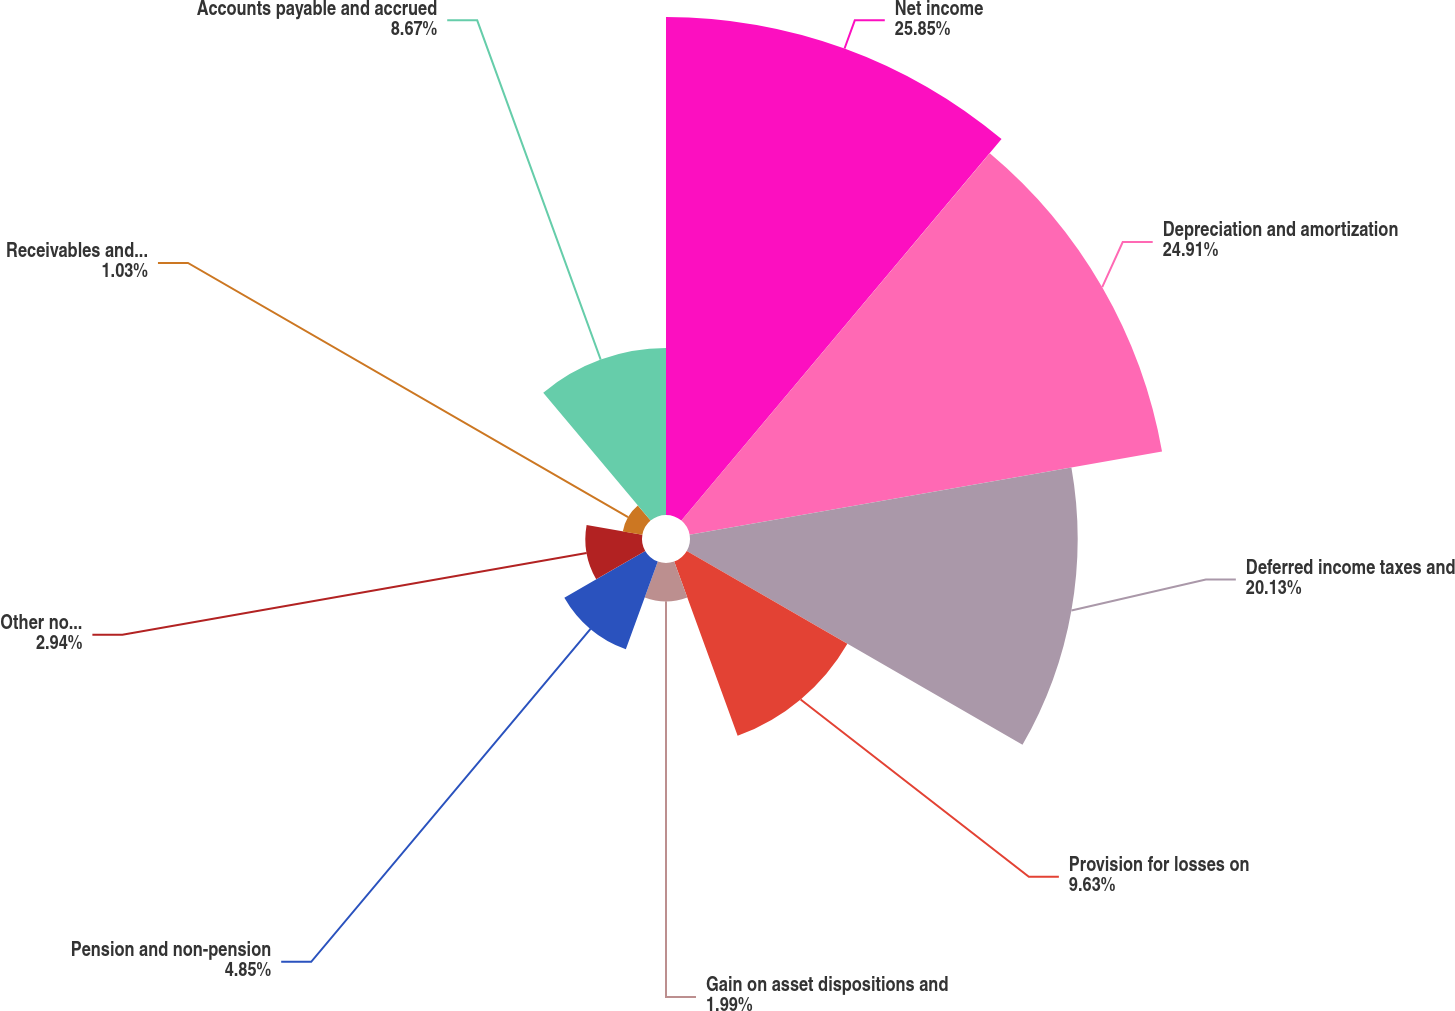Convert chart to OTSL. <chart><loc_0><loc_0><loc_500><loc_500><pie_chart><fcel>Net income<fcel>Depreciation and amortization<fcel>Deferred income taxes and<fcel>Provision for losses on<fcel>Gain on asset dispositions and<fcel>Pension and non-pension<fcel>Other non-cash net<fcel>Receivables and unbilled<fcel>Accounts payable and accrued<nl><fcel>25.86%<fcel>24.91%<fcel>20.13%<fcel>9.63%<fcel>1.99%<fcel>4.85%<fcel>2.94%<fcel>1.03%<fcel>8.67%<nl></chart> 